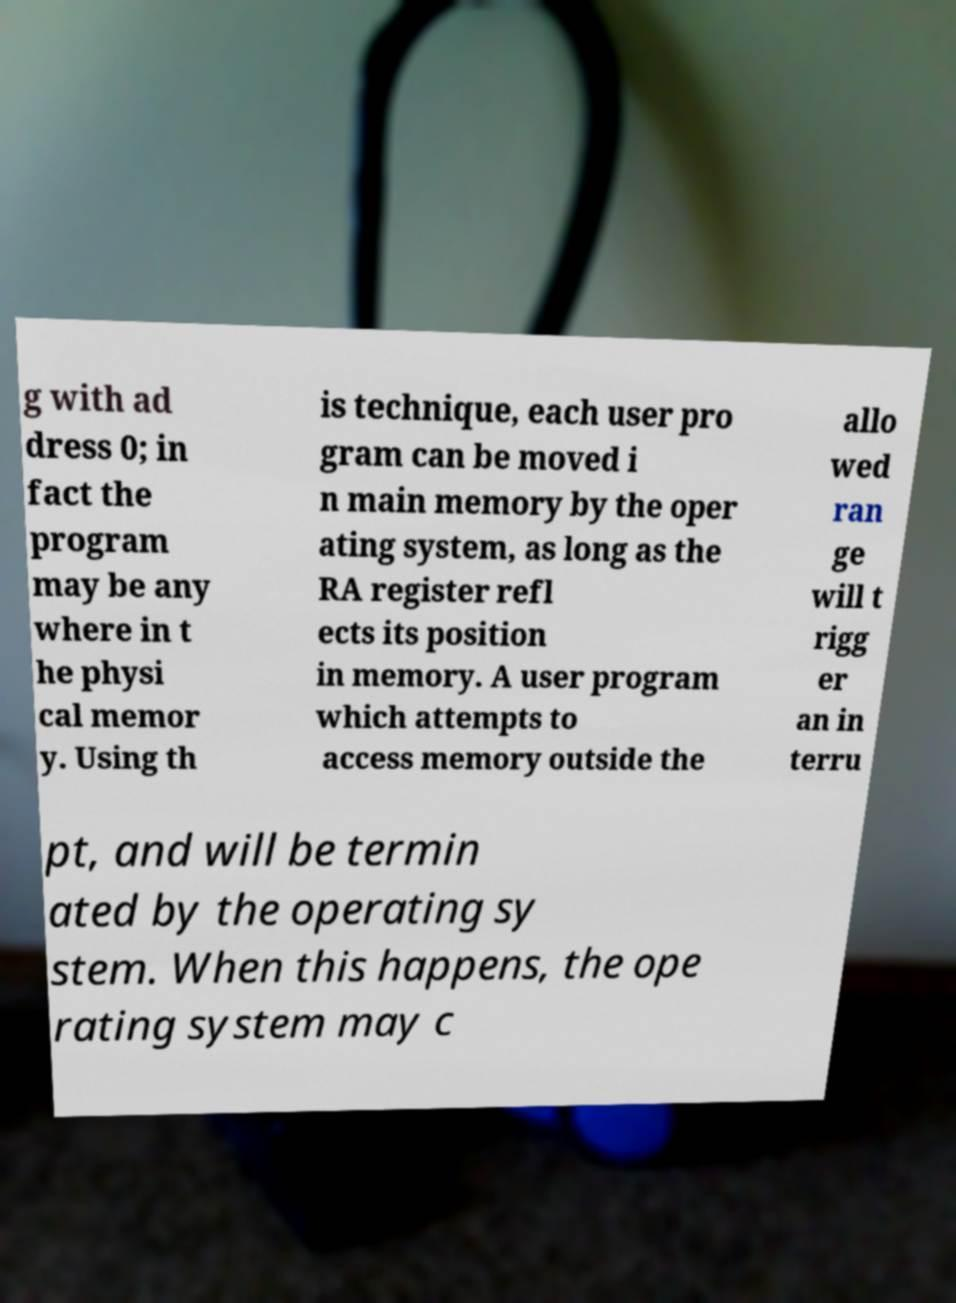Please identify and transcribe the text found in this image. g with ad dress 0; in fact the program may be any where in t he physi cal memor y. Using th is technique, each user pro gram can be moved i n main memory by the oper ating system, as long as the RA register refl ects its position in memory. A user program which attempts to access memory outside the allo wed ran ge will t rigg er an in terru pt, and will be termin ated by the operating sy stem. When this happens, the ope rating system may c 